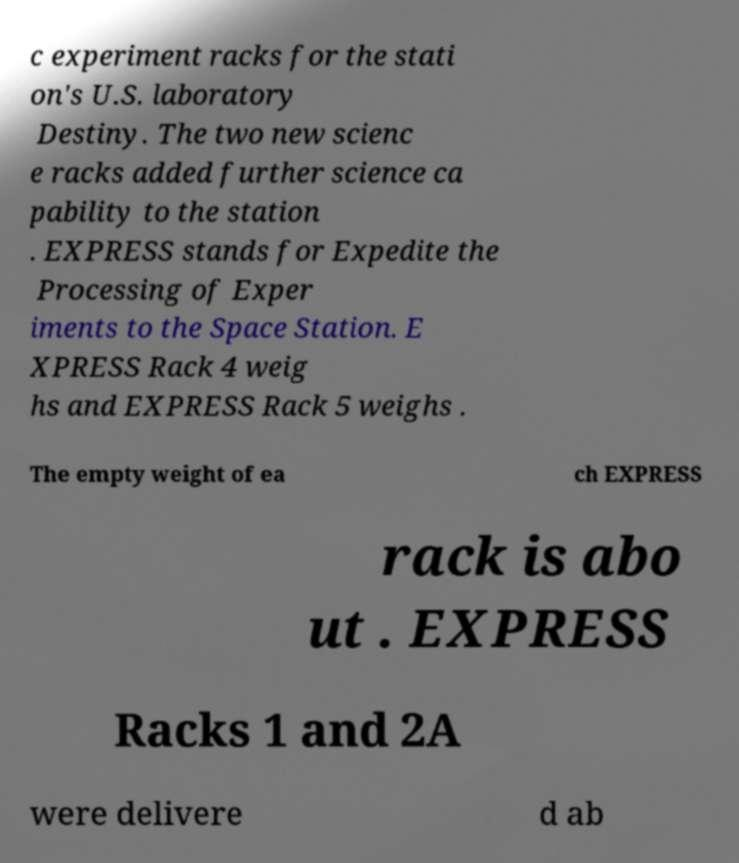I need the written content from this picture converted into text. Can you do that? c experiment racks for the stati on's U.S. laboratory Destiny. The two new scienc e racks added further science ca pability to the station . EXPRESS stands for Expedite the Processing of Exper iments to the Space Station. E XPRESS Rack 4 weig hs and EXPRESS Rack 5 weighs . The empty weight of ea ch EXPRESS rack is abo ut . EXPRESS Racks 1 and 2A were delivere d ab 